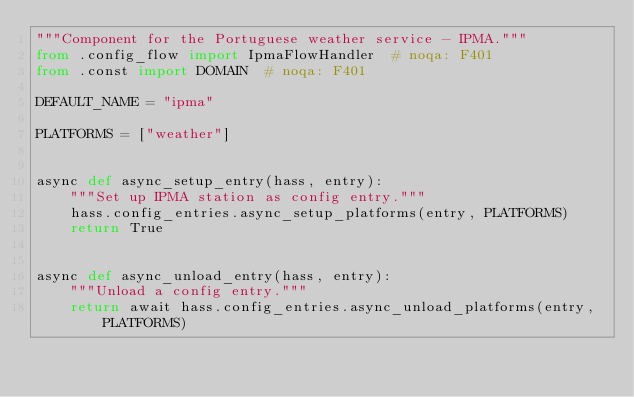<code> <loc_0><loc_0><loc_500><loc_500><_Python_>"""Component for the Portuguese weather service - IPMA."""
from .config_flow import IpmaFlowHandler  # noqa: F401
from .const import DOMAIN  # noqa: F401

DEFAULT_NAME = "ipma"

PLATFORMS = ["weather"]


async def async_setup_entry(hass, entry):
    """Set up IPMA station as config entry."""
    hass.config_entries.async_setup_platforms(entry, PLATFORMS)
    return True


async def async_unload_entry(hass, entry):
    """Unload a config entry."""
    return await hass.config_entries.async_unload_platforms(entry, PLATFORMS)
</code> 